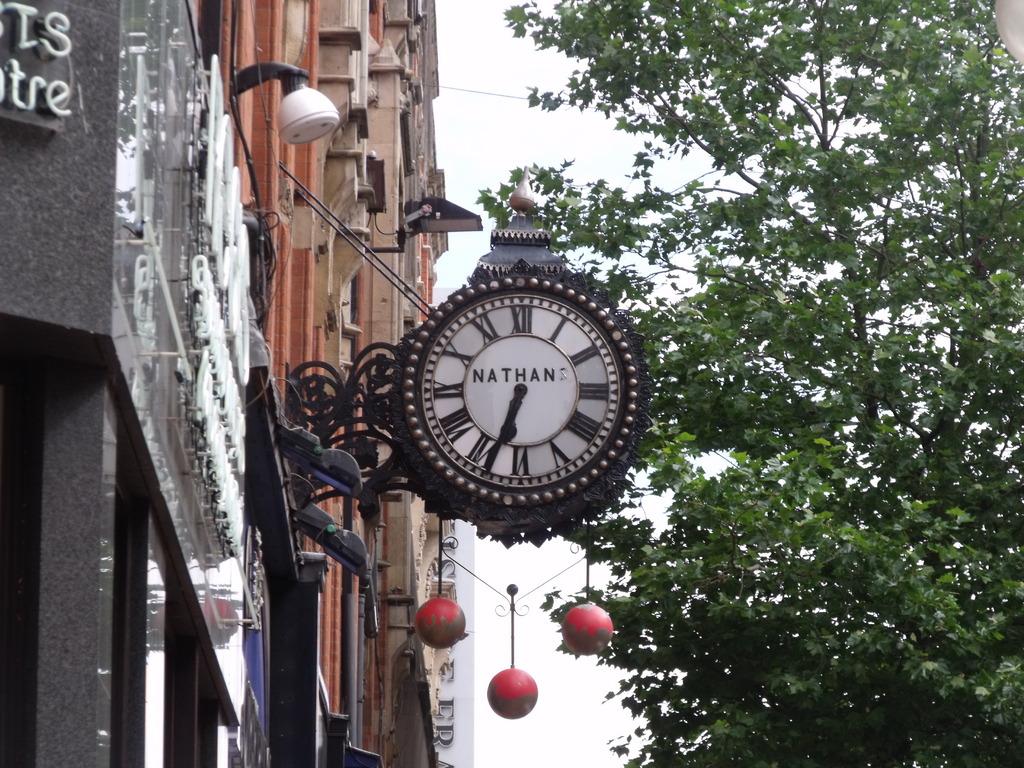What does it say on the clock?
Ensure brevity in your answer.  Nathan. What time does the clock show?
Ensure brevity in your answer.  6:35. 